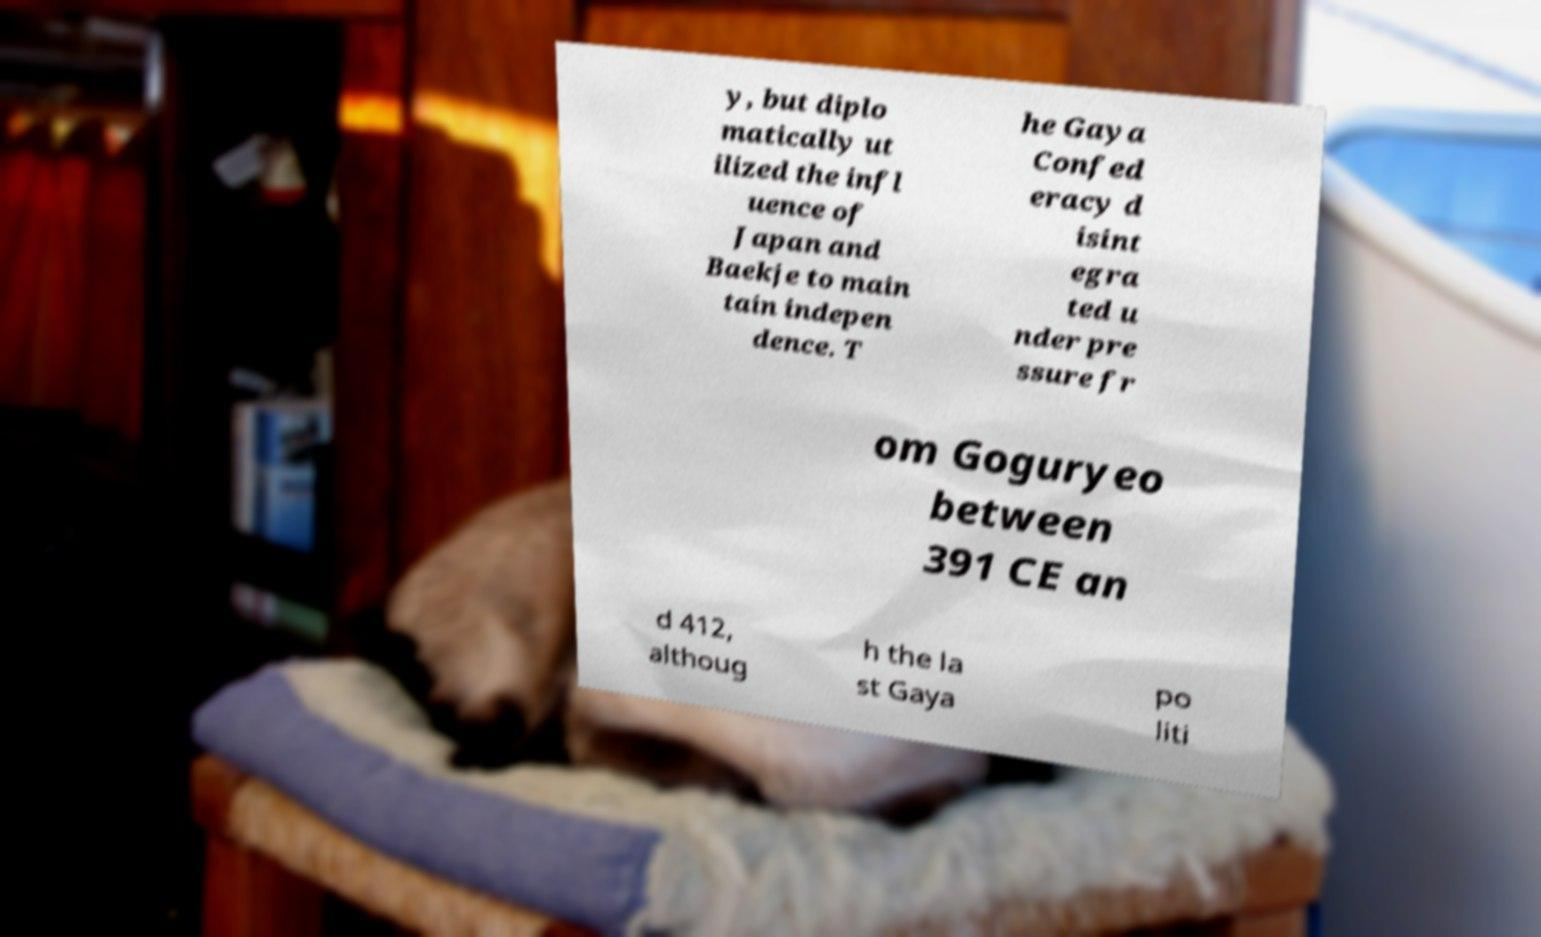Can you read and provide the text displayed in the image?This photo seems to have some interesting text. Can you extract and type it out for me? y, but diplo matically ut ilized the infl uence of Japan and Baekje to main tain indepen dence. T he Gaya Confed eracy d isint egra ted u nder pre ssure fr om Goguryeo between 391 CE an d 412, althoug h the la st Gaya po liti 